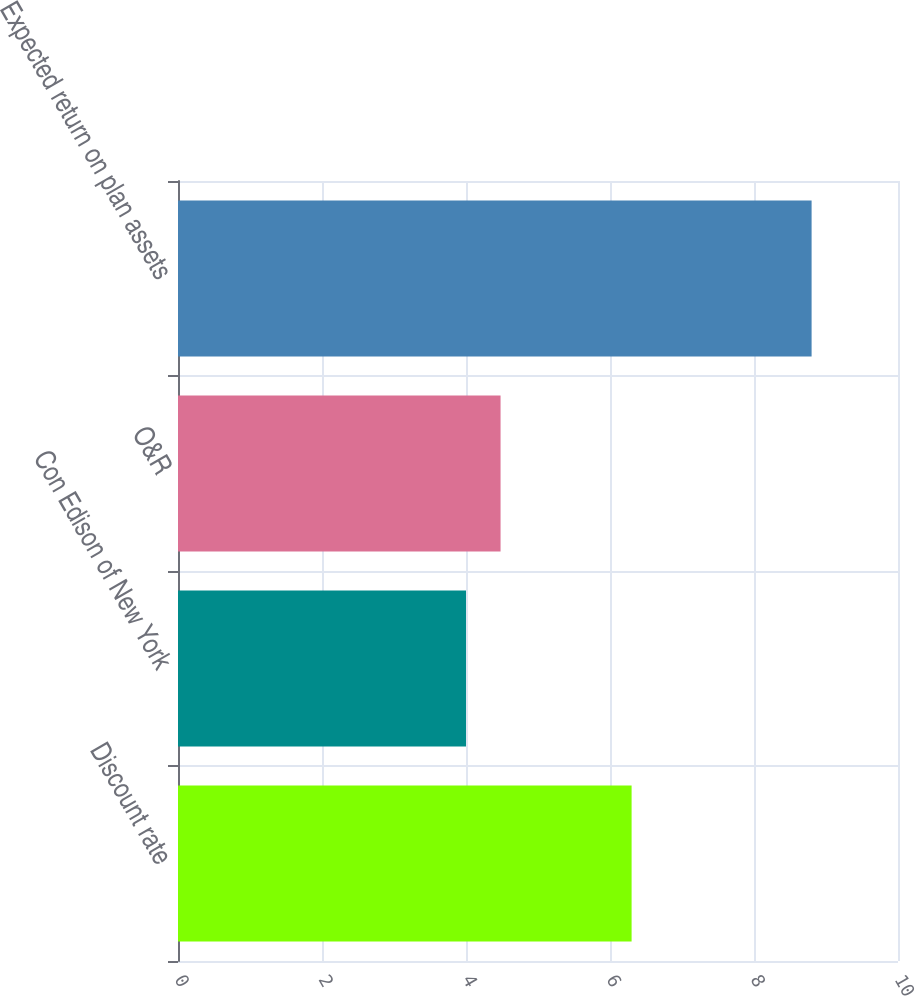<chart> <loc_0><loc_0><loc_500><loc_500><bar_chart><fcel>Discount rate<fcel>Con Edison of New York<fcel>O&R<fcel>Expected return on plan assets<nl><fcel>6.3<fcel>4<fcel>4.48<fcel>8.8<nl></chart> 